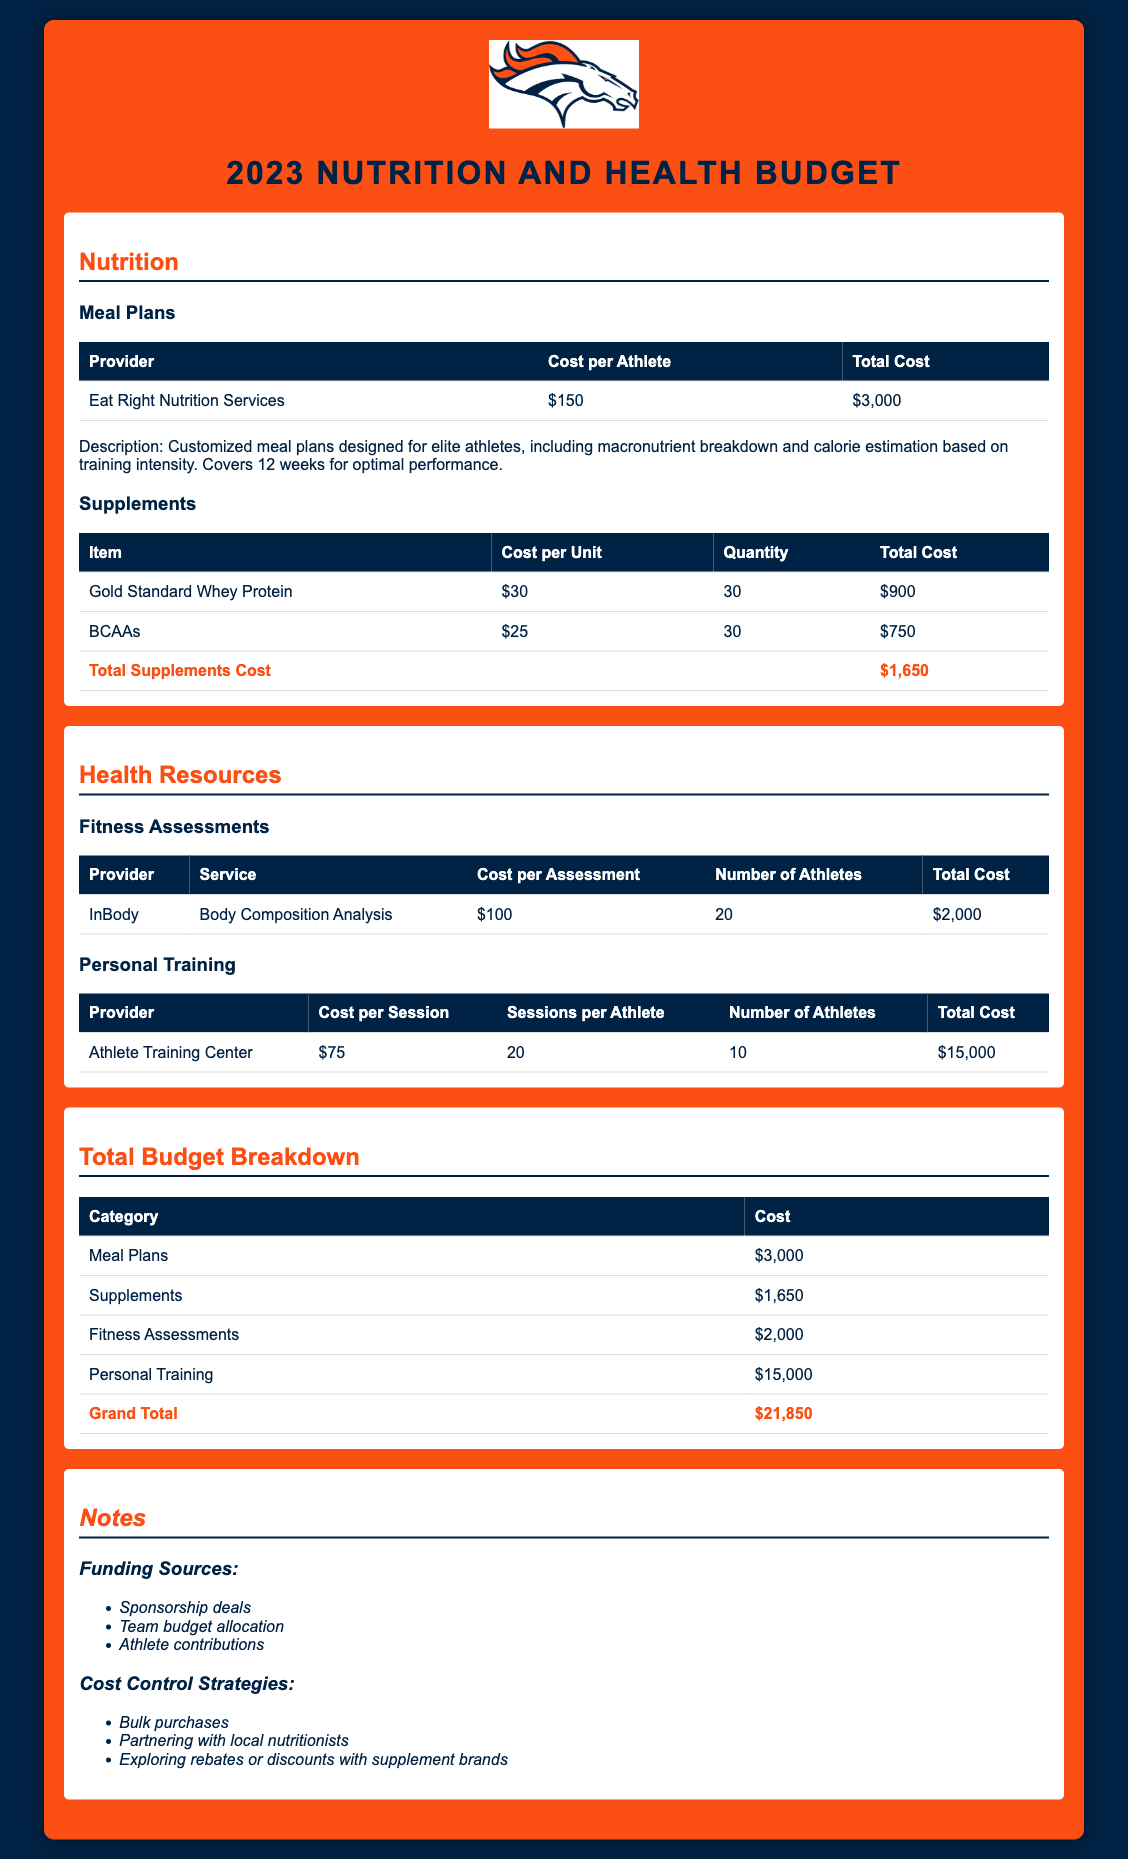What is the total cost for meal plans? The total cost for meal plans is specifically listed in the document under the Nutrition section, which states it as $3,000.
Answer: $3,000 What is the cost per unit of BCAAs? The document provides the cost per unit of BCAAs in the Supplements section, which is $25.
Answer: $25 How many athletes are assessed for body composition analysis? The document states that 20 athletes are assessed for body composition analysis under the Fitness Assessments section.
Answer: 20 What is the total budget for the 2023 training season? The grand total for the budget is mentioned at the end of the Total Budget Breakdown section, which sums to $21,850.
Answer: $21,850 Which provider offers personal training sessions? The document lists the Athlete Training Center as the provider for personal training sessions in the Health Resources section.
Answer: Athlete Training Center What is the total cost for supplements? The total cost for supplements is added up at the end of the Supplements section, which is $1,650.
Answer: $1,650 What funding source is mentioned for the budget? The document lists several funding sources, one of which is sponsorship deals as indicated in the Notes section.
Answer: Sponsorship deals How many sessions are provided per athlete for personal training? The document states that each athlete receives 20 sessions for personal training as shown in that section.
Answer: 20 What is the cost per assessment for fitness evaluations? The cost per assessment for body composition analysis is specifically stated to be $100 in the Fitness Assessments table.
Answer: $100 